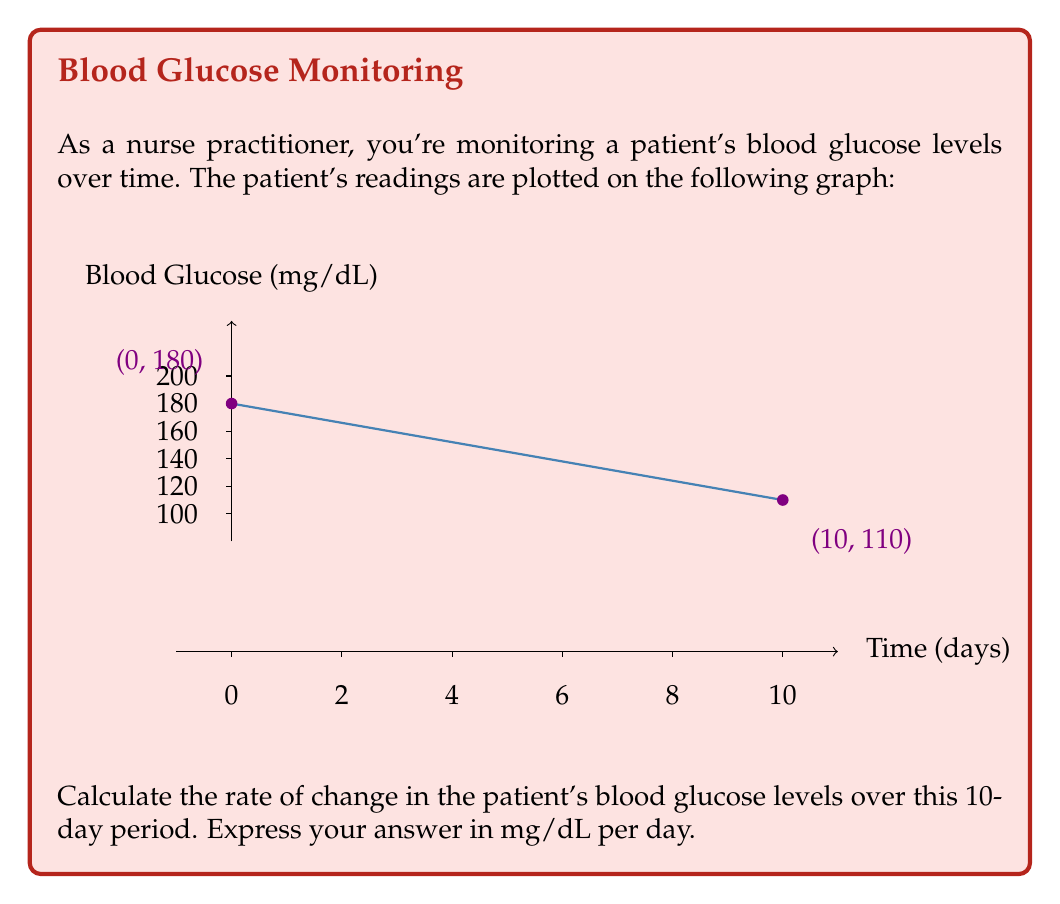Show me your answer to this math problem. To determine the rate of change, we need to calculate the slope of the line connecting the two points on the graph. The slope represents the change in blood glucose levels per unit of time.

Let's follow these steps:

1) Identify the two points:
   Point 1: $(x_1, y_1) = (0, 180)$
   Point 2: $(x_2, y_2) = (10, 110)$

2) Use the slope formula:
   $$\text{slope} = \frac{y_2 - y_1}{x_2 - x_1}$$

3) Substitute the values:
   $$\text{slope} = \frac{110 - 180}{10 - 0} = \frac{-70}{10}$$

4) Simplify:
   $$\text{slope} = -7$$

The slope is -7 mg/dL per day, indicating that the patient's blood glucose levels are decreasing by 7 mg/dL each day on average.
Answer: $-7$ mg/dL per day 